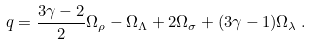Convert formula to latex. <formula><loc_0><loc_0><loc_500><loc_500>q = \frac { 3 \gamma - 2 } { 2 } \Omega _ { \rho } - \Omega _ { \Lambda } + 2 \Omega _ { \sigma } + ( 3 \gamma - 1 ) \Omega _ { \lambda } \, .</formula> 